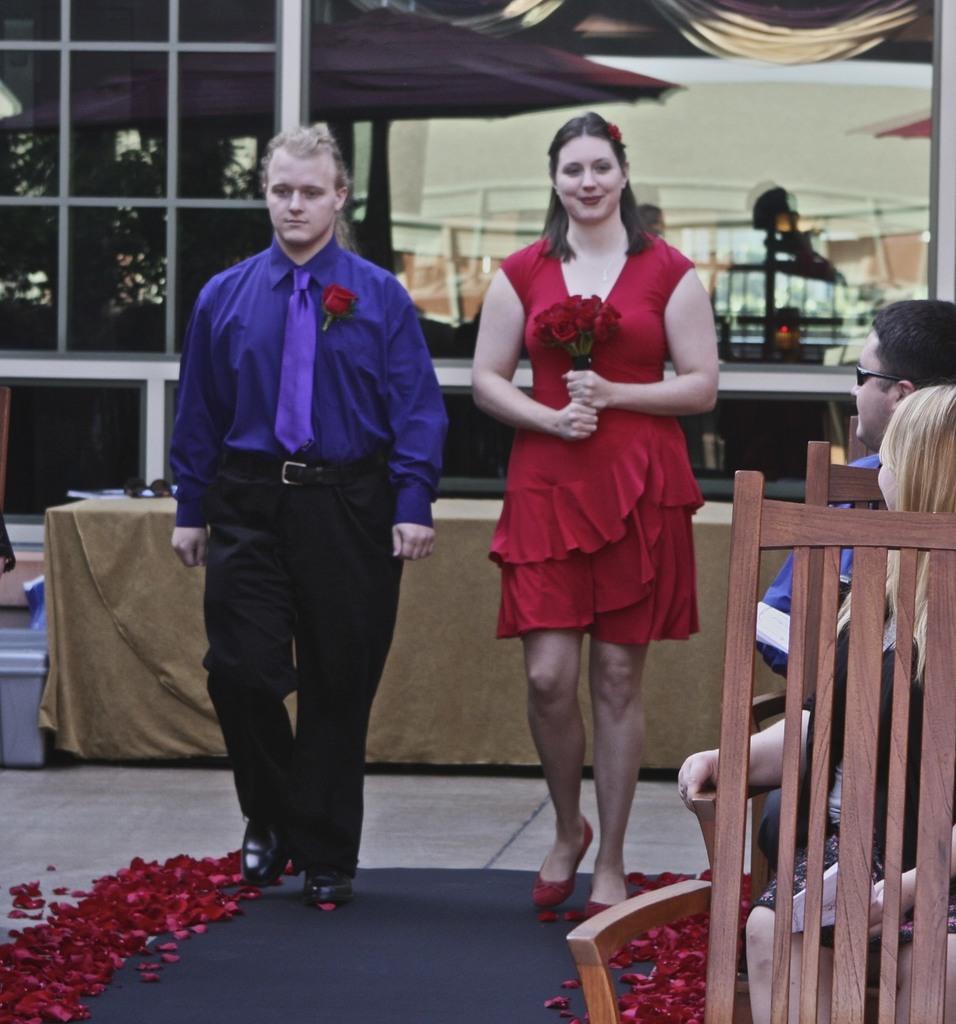Describe this image in one or two sentences. In this picture there are two people were walking on the floor, the floor is covered with a black color mat on the mat there are the red flower petals. The man is in blue shirt with blue tie and the woman is in red dress holding the flowers. In front of the women there are the chairs on the chairs there are persons are siting. Background of the two people there is a table and the table is covered with gold cloth and there is a glass windows. 